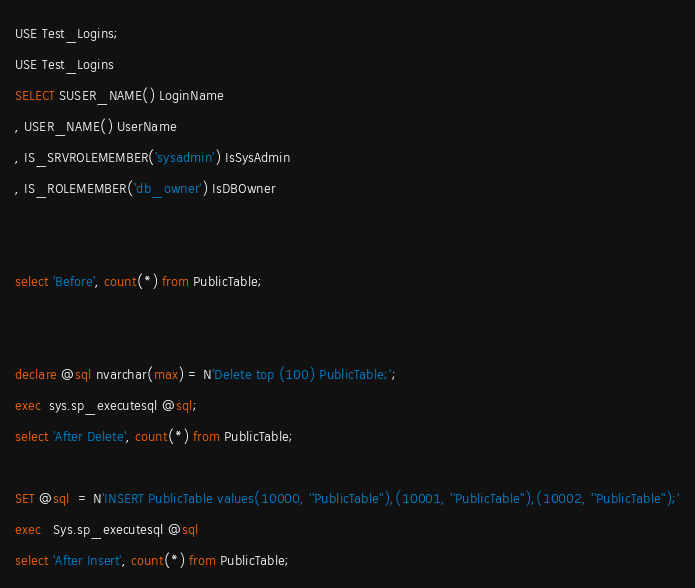Convert code to text. <code><loc_0><loc_0><loc_500><loc_500><_SQL_>USE Test_Logins;
USE Test_Logins
SELECT SUSER_NAME() LoginName
, USER_NAME() UserName
, IS_SRVROLEMEMBER('sysadmin') IsSysAdmin
, IS_ROLEMEMBER('db_owner') IsDBOwner 


select 'Before', count(*) from PublicTable;
 

declare @sql nvarchar(max) = N'Delete top (100) PublicTable;';
exec  sys.sp_executesql @sql;
select 'After Delete', count(*) from PublicTable;

SET @sql  = N'INSERT PublicTable values(10000, ''PublicTable''),(10001, ''PublicTable''),(10002, ''PublicTable'');'
exec   Sys.sp_executesql @sql
select 'After Insert', count(*) from PublicTable;
</code> 